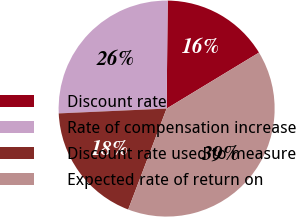Convert chart to OTSL. <chart><loc_0><loc_0><loc_500><loc_500><pie_chart><fcel>Discount rate<fcel>Rate of compensation increase<fcel>Discount rate used to measure<fcel>Expected rate of return on<nl><fcel>16.17%<fcel>25.87%<fcel>18.5%<fcel>39.46%<nl></chart> 